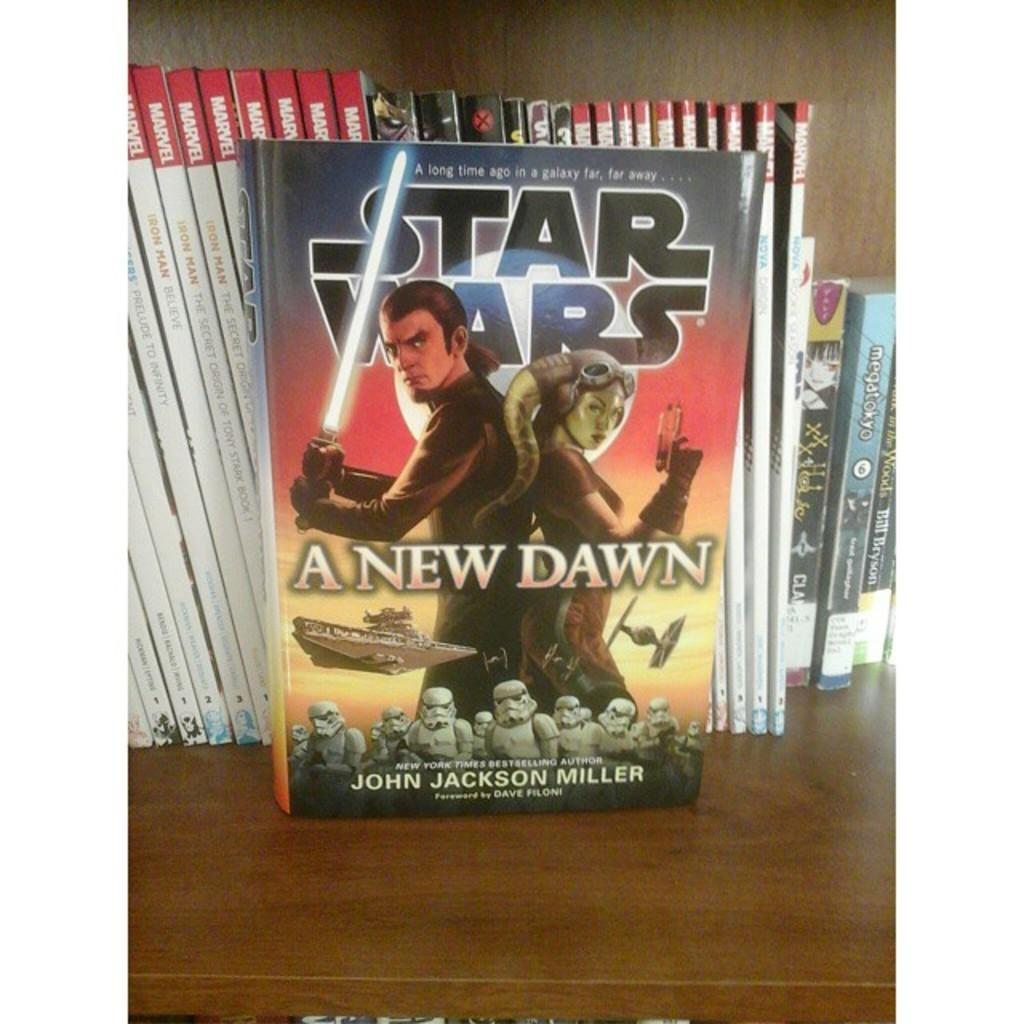<image>
Relay a brief, clear account of the picture shown. Star Wars a New Dawn, by John Jackson Miller, is sitting in front of other comics. 